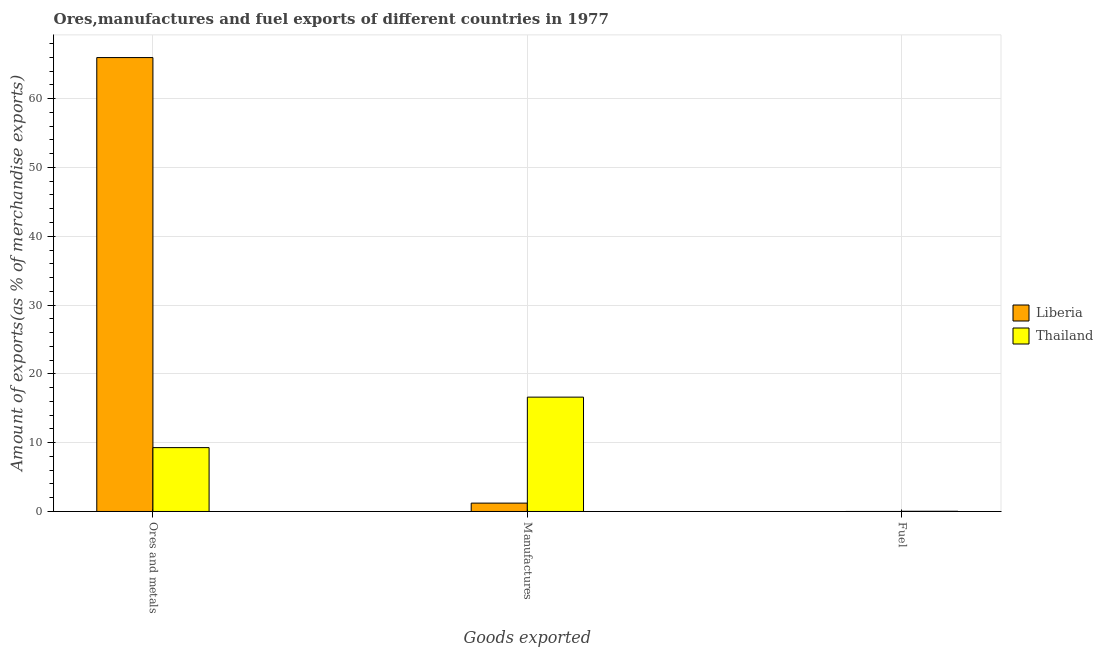How many different coloured bars are there?
Ensure brevity in your answer.  2. Are the number of bars per tick equal to the number of legend labels?
Provide a short and direct response. Yes. How many bars are there on the 1st tick from the left?
Your answer should be very brief. 2. How many bars are there on the 3rd tick from the right?
Provide a succinct answer. 2. What is the label of the 2nd group of bars from the left?
Ensure brevity in your answer.  Manufactures. What is the percentage of manufactures exports in Thailand?
Keep it short and to the point. 16.62. Across all countries, what is the maximum percentage of fuel exports?
Make the answer very short. 0.03. Across all countries, what is the minimum percentage of ores and metals exports?
Offer a very short reply. 9.28. In which country was the percentage of ores and metals exports maximum?
Your answer should be very brief. Liberia. In which country was the percentage of ores and metals exports minimum?
Ensure brevity in your answer.  Thailand. What is the total percentage of ores and metals exports in the graph?
Offer a terse response. 75.26. What is the difference between the percentage of fuel exports in Liberia and that in Thailand?
Your response must be concise. -0.03. What is the difference between the percentage of fuel exports in Thailand and the percentage of ores and metals exports in Liberia?
Your response must be concise. -65.94. What is the average percentage of fuel exports per country?
Ensure brevity in your answer.  0.02. What is the difference between the percentage of manufactures exports and percentage of ores and metals exports in Liberia?
Your answer should be very brief. -64.76. What is the ratio of the percentage of fuel exports in Thailand to that in Liberia?
Offer a terse response. 15.08. Is the difference between the percentage of ores and metals exports in Liberia and Thailand greater than the difference between the percentage of manufactures exports in Liberia and Thailand?
Your answer should be very brief. Yes. What is the difference between the highest and the second highest percentage of ores and metals exports?
Offer a very short reply. 56.69. What is the difference between the highest and the lowest percentage of manufactures exports?
Keep it short and to the point. 15.4. What does the 2nd bar from the left in Ores and metals represents?
Keep it short and to the point. Thailand. What does the 2nd bar from the right in Manufactures represents?
Your response must be concise. Liberia. How many bars are there?
Offer a terse response. 6. Are all the bars in the graph horizontal?
Provide a succinct answer. No. What is the difference between two consecutive major ticks on the Y-axis?
Your answer should be compact. 10. Are the values on the major ticks of Y-axis written in scientific E-notation?
Your response must be concise. No. Does the graph contain any zero values?
Give a very brief answer. No. How many legend labels are there?
Make the answer very short. 2. What is the title of the graph?
Give a very brief answer. Ores,manufactures and fuel exports of different countries in 1977. Does "Montenegro" appear as one of the legend labels in the graph?
Your response must be concise. No. What is the label or title of the X-axis?
Your response must be concise. Goods exported. What is the label or title of the Y-axis?
Provide a short and direct response. Amount of exports(as % of merchandise exports). What is the Amount of exports(as % of merchandise exports) in Liberia in Ores and metals?
Ensure brevity in your answer.  65.97. What is the Amount of exports(as % of merchandise exports) of Thailand in Ores and metals?
Keep it short and to the point. 9.28. What is the Amount of exports(as % of merchandise exports) of Liberia in Manufactures?
Make the answer very short. 1.22. What is the Amount of exports(as % of merchandise exports) of Thailand in Manufactures?
Your response must be concise. 16.62. What is the Amount of exports(as % of merchandise exports) of Liberia in Fuel?
Give a very brief answer. 0. What is the Amount of exports(as % of merchandise exports) in Thailand in Fuel?
Offer a terse response. 0.03. Across all Goods exported, what is the maximum Amount of exports(as % of merchandise exports) in Liberia?
Your answer should be compact. 65.97. Across all Goods exported, what is the maximum Amount of exports(as % of merchandise exports) of Thailand?
Provide a succinct answer. 16.62. Across all Goods exported, what is the minimum Amount of exports(as % of merchandise exports) of Liberia?
Make the answer very short. 0. Across all Goods exported, what is the minimum Amount of exports(as % of merchandise exports) of Thailand?
Your answer should be compact. 0.03. What is the total Amount of exports(as % of merchandise exports) of Liberia in the graph?
Provide a short and direct response. 67.19. What is the total Amount of exports(as % of merchandise exports) in Thailand in the graph?
Your answer should be compact. 25.93. What is the difference between the Amount of exports(as % of merchandise exports) of Liberia in Ores and metals and that in Manufactures?
Make the answer very short. 64.76. What is the difference between the Amount of exports(as % of merchandise exports) of Thailand in Ores and metals and that in Manufactures?
Give a very brief answer. -7.34. What is the difference between the Amount of exports(as % of merchandise exports) of Liberia in Ores and metals and that in Fuel?
Keep it short and to the point. 65.97. What is the difference between the Amount of exports(as % of merchandise exports) of Thailand in Ores and metals and that in Fuel?
Your answer should be very brief. 9.25. What is the difference between the Amount of exports(as % of merchandise exports) of Liberia in Manufactures and that in Fuel?
Provide a short and direct response. 1.21. What is the difference between the Amount of exports(as % of merchandise exports) in Thailand in Manufactures and that in Fuel?
Ensure brevity in your answer.  16.59. What is the difference between the Amount of exports(as % of merchandise exports) of Liberia in Ores and metals and the Amount of exports(as % of merchandise exports) of Thailand in Manufactures?
Offer a terse response. 49.35. What is the difference between the Amount of exports(as % of merchandise exports) of Liberia in Ores and metals and the Amount of exports(as % of merchandise exports) of Thailand in Fuel?
Make the answer very short. 65.94. What is the difference between the Amount of exports(as % of merchandise exports) in Liberia in Manufactures and the Amount of exports(as % of merchandise exports) in Thailand in Fuel?
Your response must be concise. 1.19. What is the average Amount of exports(as % of merchandise exports) in Liberia per Goods exported?
Keep it short and to the point. 22.4. What is the average Amount of exports(as % of merchandise exports) in Thailand per Goods exported?
Offer a terse response. 8.64. What is the difference between the Amount of exports(as % of merchandise exports) of Liberia and Amount of exports(as % of merchandise exports) of Thailand in Ores and metals?
Your answer should be very brief. 56.69. What is the difference between the Amount of exports(as % of merchandise exports) of Liberia and Amount of exports(as % of merchandise exports) of Thailand in Manufactures?
Provide a succinct answer. -15.4. What is the difference between the Amount of exports(as % of merchandise exports) of Liberia and Amount of exports(as % of merchandise exports) of Thailand in Fuel?
Offer a terse response. -0.03. What is the ratio of the Amount of exports(as % of merchandise exports) of Liberia in Ores and metals to that in Manufactures?
Ensure brevity in your answer.  54.21. What is the ratio of the Amount of exports(as % of merchandise exports) in Thailand in Ores and metals to that in Manufactures?
Provide a succinct answer. 0.56. What is the ratio of the Amount of exports(as % of merchandise exports) of Liberia in Ores and metals to that in Fuel?
Give a very brief answer. 3.35e+04. What is the ratio of the Amount of exports(as % of merchandise exports) in Thailand in Ores and metals to that in Fuel?
Give a very brief answer. 312.24. What is the ratio of the Amount of exports(as % of merchandise exports) in Liberia in Manufactures to that in Fuel?
Offer a very short reply. 617.32. What is the ratio of the Amount of exports(as % of merchandise exports) of Thailand in Manufactures to that in Fuel?
Provide a short and direct response. 559.08. What is the difference between the highest and the second highest Amount of exports(as % of merchandise exports) in Liberia?
Your answer should be compact. 64.76. What is the difference between the highest and the second highest Amount of exports(as % of merchandise exports) of Thailand?
Ensure brevity in your answer.  7.34. What is the difference between the highest and the lowest Amount of exports(as % of merchandise exports) in Liberia?
Ensure brevity in your answer.  65.97. What is the difference between the highest and the lowest Amount of exports(as % of merchandise exports) of Thailand?
Your response must be concise. 16.59. 